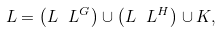<formula> <loc_0><loc_0><loc_500><loc_500>L = \left ( L \ L ^ { G } \right ) \cup \left ( L \ L ^ { H } \right ) \cup K ,</formula> 